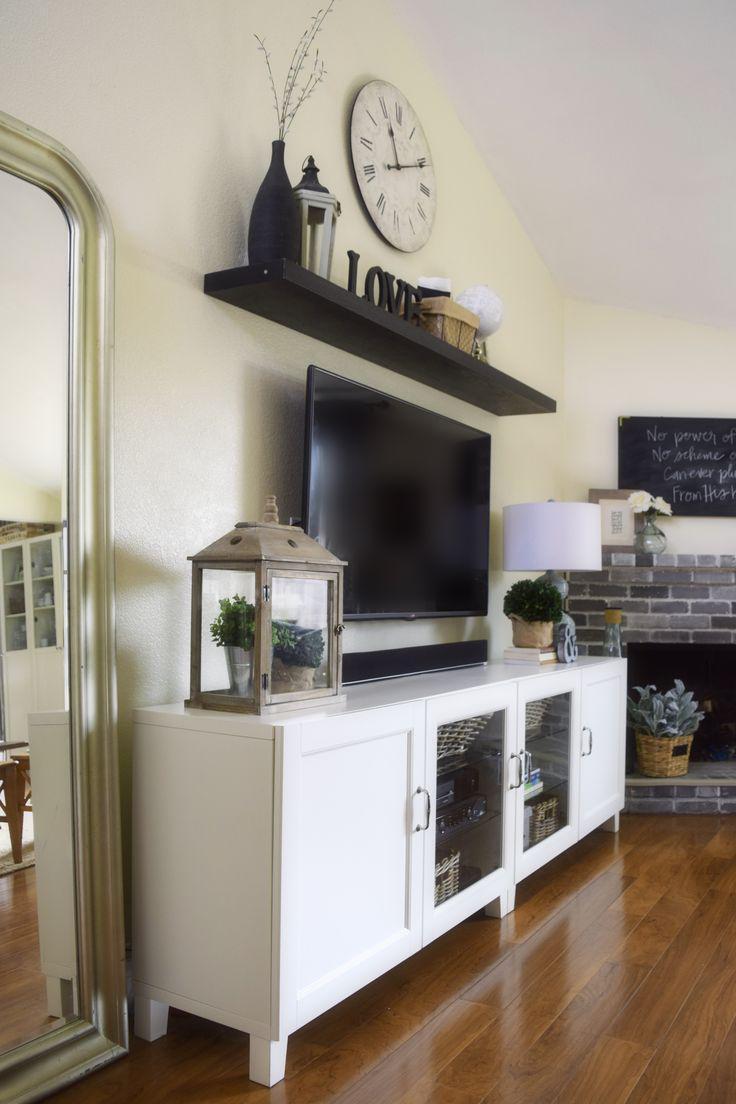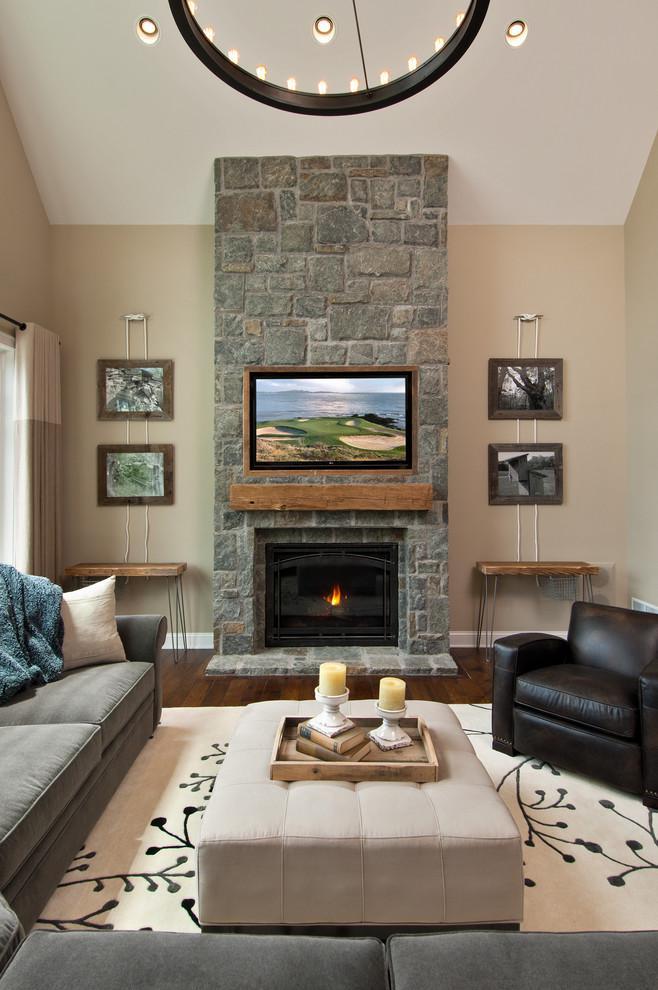The first image is the image on the left, the second image is the image on the right. Evaluate the accuracy of this statement regarding the images: "There is a least one individual letter hanging near a TV.". Is it true? Answer yes or no. No. The first image is the image on the left, the second image is the image on the right. Given the left and right images, does the statement "there is at least one clock on the wall behind the tv" hold true? Answer yes or no. Yes. 